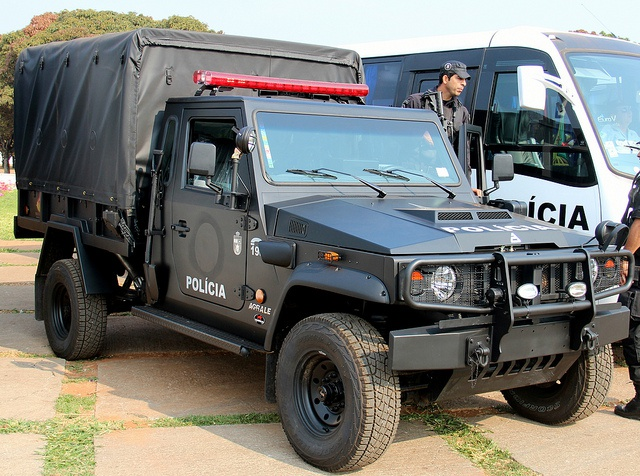Describe the objects in this image and their specific colors. I can see truck in white, black, gray, darkgray, and lightblue tones, bus in white, black, lightblue, and blue tones, people in white, gray, black, and darkgray tones, people in white, black, gray, salmon, and tan tones, and people in white, lightblue, gray, and darkgray tones in this image. 